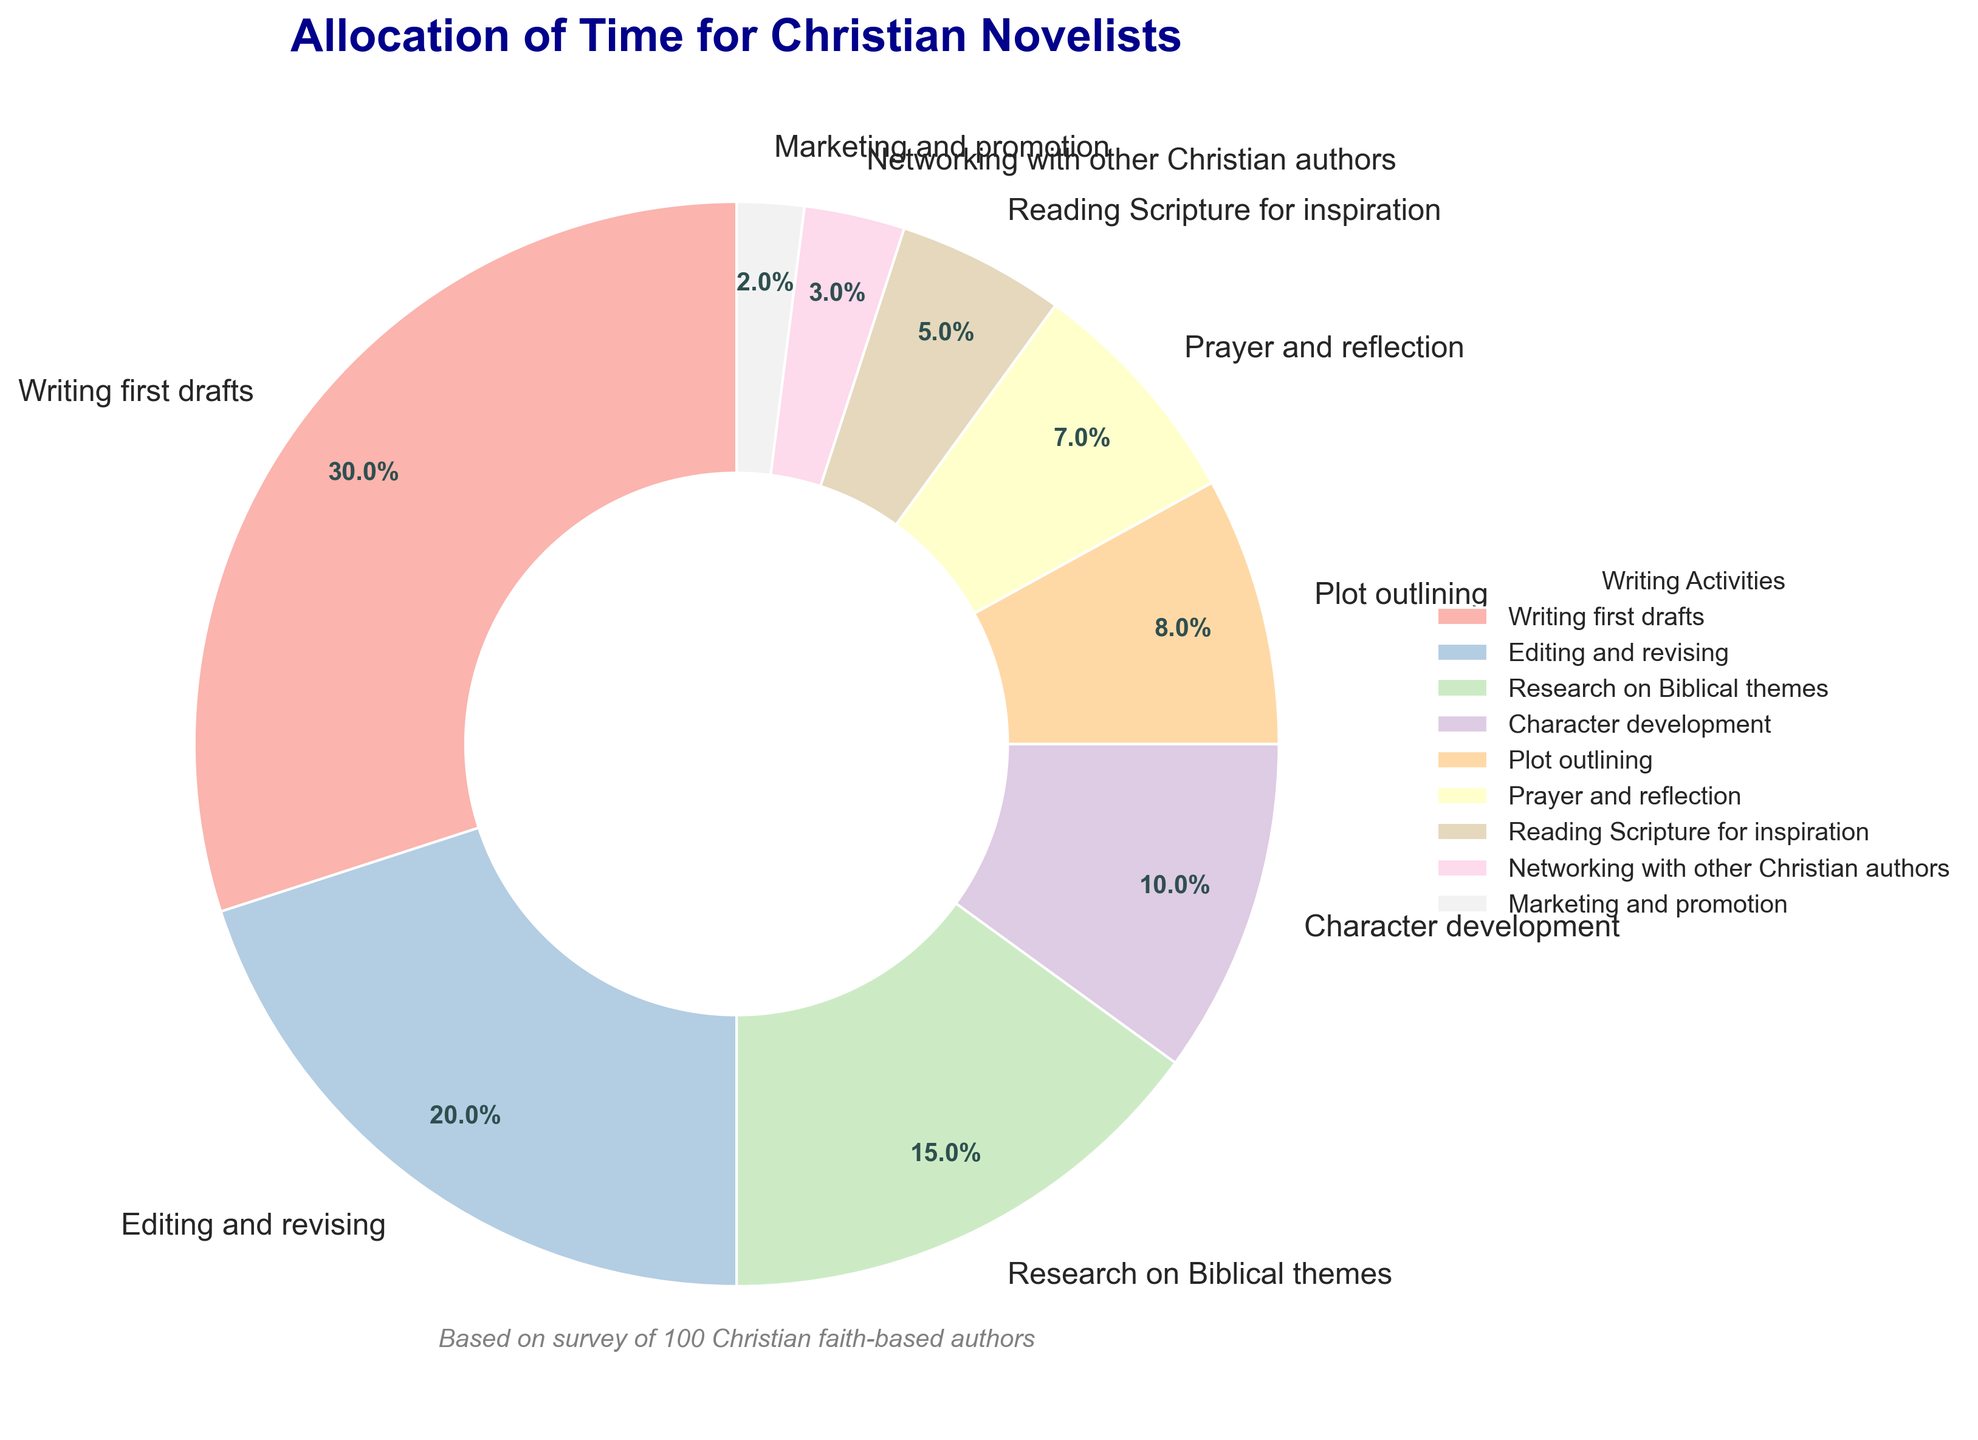What is the largest single allocation of time for Christian novelists? The largest single allocation of time is represented by the biggest wedge on the pie chart, which is labeled "Writing first drafts" with 30%.
Answer: Writing first drafts (30%) Which activity takes up more time, editing and revising or research on Biblical themes? To determine this, compare the percentages for "Editing and revising" (20%) and "Research on Biblical themes" (15%). Editing and revising is larger.
Answer: Editing and revising What is the combined time spent on character development and plot outlining? Sum the percentages of "Character development" (10%) and "Plot outlining" (8%), which gives 10% + 8% = 18%.
Answer: 18% How much more time is allocated to prayer and reflection compared to marketing and promotion? Subtract the percentage of "Marketing and promotion" (2%) from "Prayer and reflection" (7%), which gives 7% - 2% = 5%.
Answer: 5% Rank the top three activities in terms of time allocation. The top three activities by their wedge sizes and percentages are: 1. "Writing first drafts" (30%), 2. "Editing and revising" (20%), 3. "Research on Biblical themes" (15%).
Answer: Writing first drafts, Editing and revising, Research on Biblical themes What is the ratio of time spent on reading Scripture for inspiration to networking with other Christian authors? Read the percentages for "Reading Scripture for inspiration" (5%) and "Networking with other Christian authors" (3%) and form the ratio 5:3.
Answer: 5:3 How much time, in percentage, is allocated to activities other than writing first drafts and editing and revising? Sum all the activities' percentages except for "Writing first drafts" (30%) and "Editing and revising" (20%). This gives 15% + 10% + 8% + 7% + 5% + 3% + 2% = 50%.
Answer: 50% Which activities combined have an allocation of less than 10%? The activities with an allocation less than 10% are "Plot outlining" (8%), "Prayer and reflection" (7%), "Reading Scripture for inspiration" (5%), "Networking with other Christian authors" (3%), and "Marketing and promotion" (2%).
Answer: Plot outlining, Prayer and reflection, Reading Scripture for inspiration, Networking with other Christian authors, Marketing and promotion Is the time spent on networking with other Christian authors twice that of marketing and promotion? Compare the percentages "Networking with other Christian authors" (3%) and "Marketing and promotion" (2%). 3% is not twice 2%.
Answer: No 